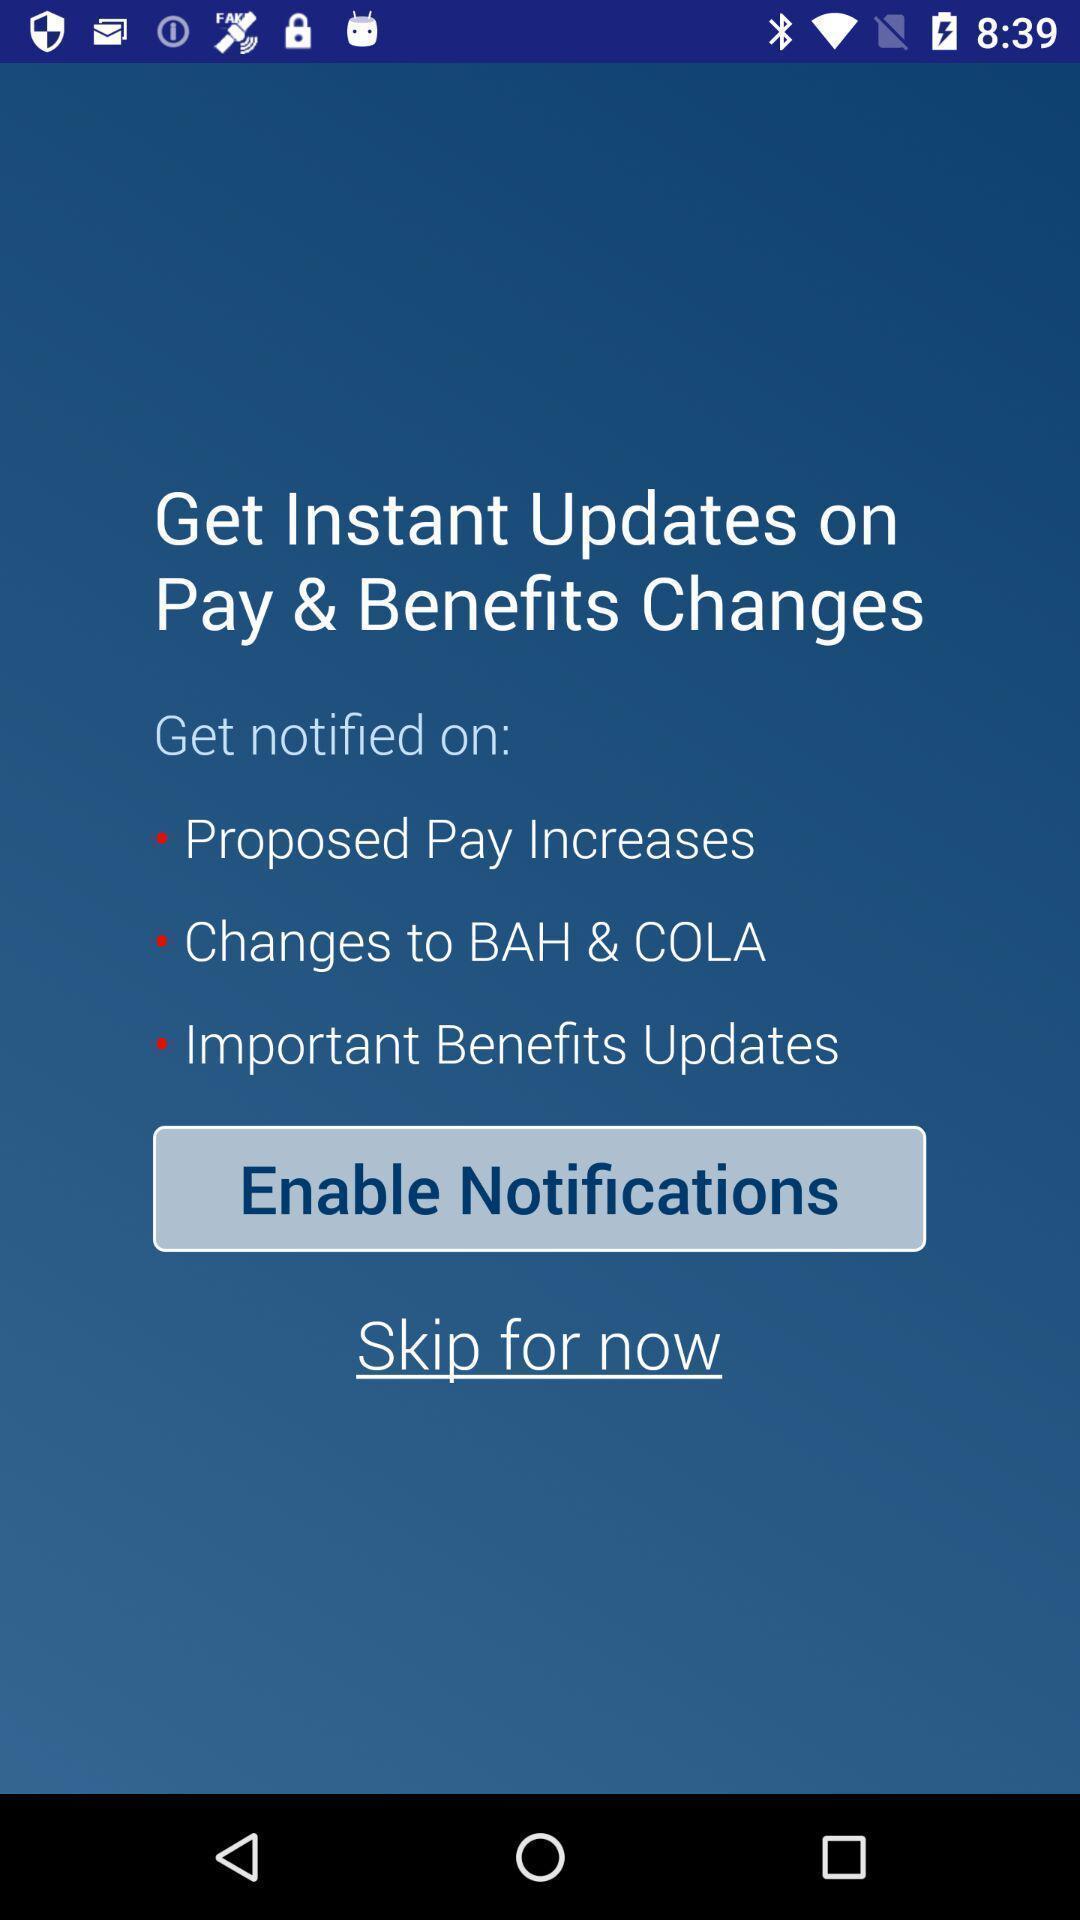Describe the key features of this screenshot. Screen shows updates page to enable notifications in financial app. 